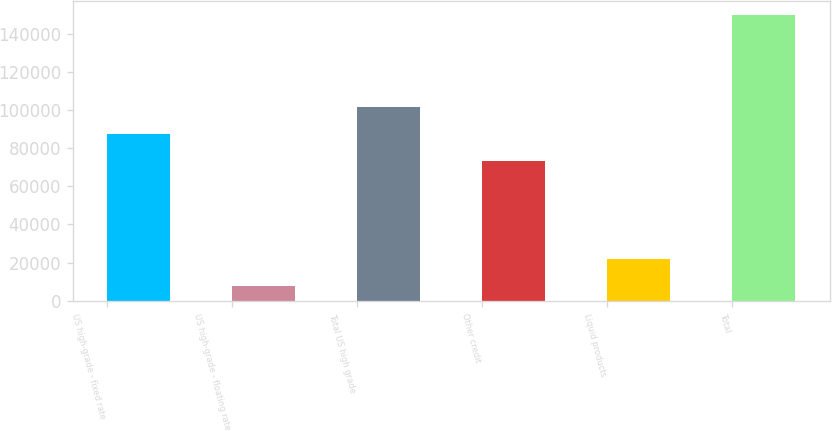<chart> <loc_0><loc_0><loc_500><loc_500><bar_chart><fcel>US high-grade - fixed rate<fcel>US high-grade - floating rate<fcel>Total US high grade<fcel>Other credit<fcel>Liquid products<fcel>Total<nl><fcel>87320.4<fcel>7922<fcel>101491<fcel>73150<fcel>22092.4<fcel>149626<nl></chart> 